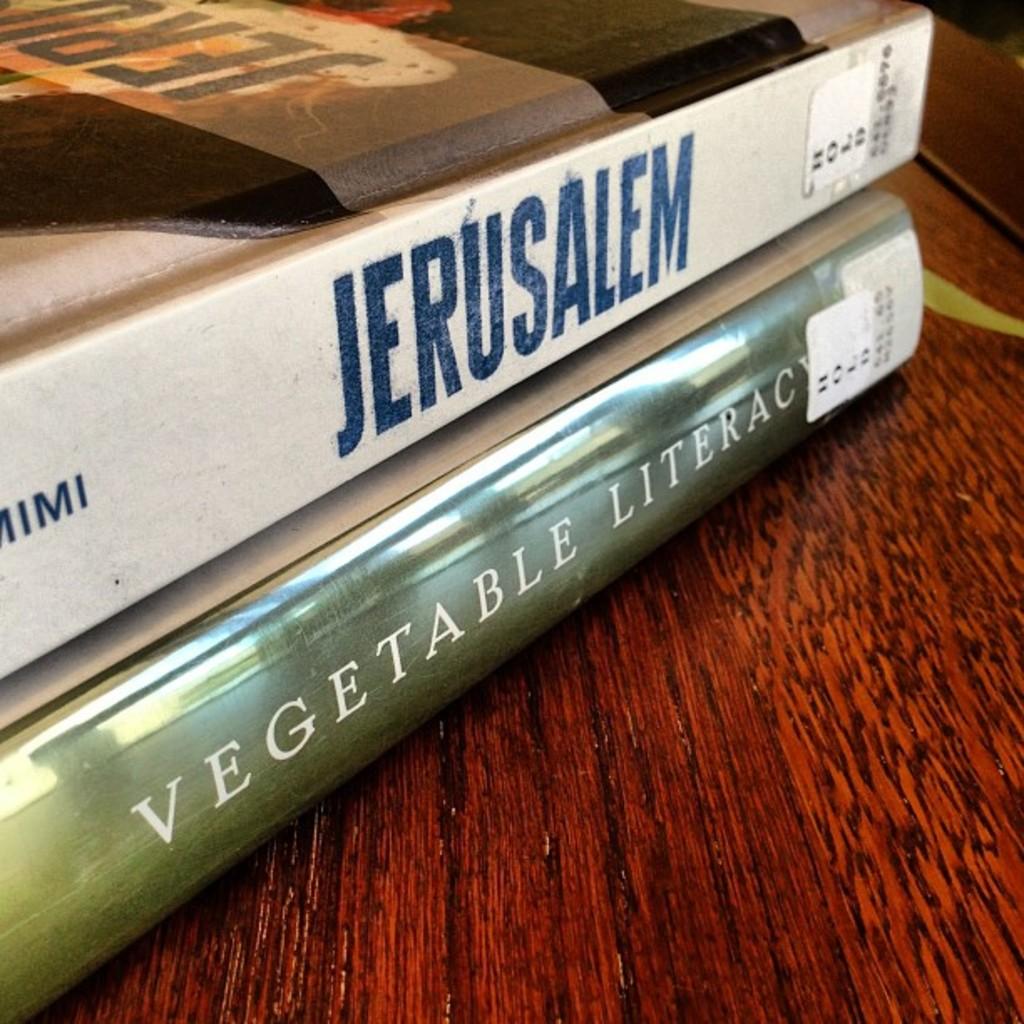What are the titles of the books?
Offer a terse response. Jerusalem, vegetable literacy. What color is the font of the first book?
Make the answer very short. Blue. 